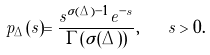Convert formula to latex. <formula><loc_0><loc_0><loc_500><loc_500>p _ { \Delta } ( s ) = \frac { s ^ { \sigma ( \Delta ) - 1 } e ^ { - s } } { \Gamma ( \sigma ( \Delta ) ) } , \quad s > 0 .</formula> 